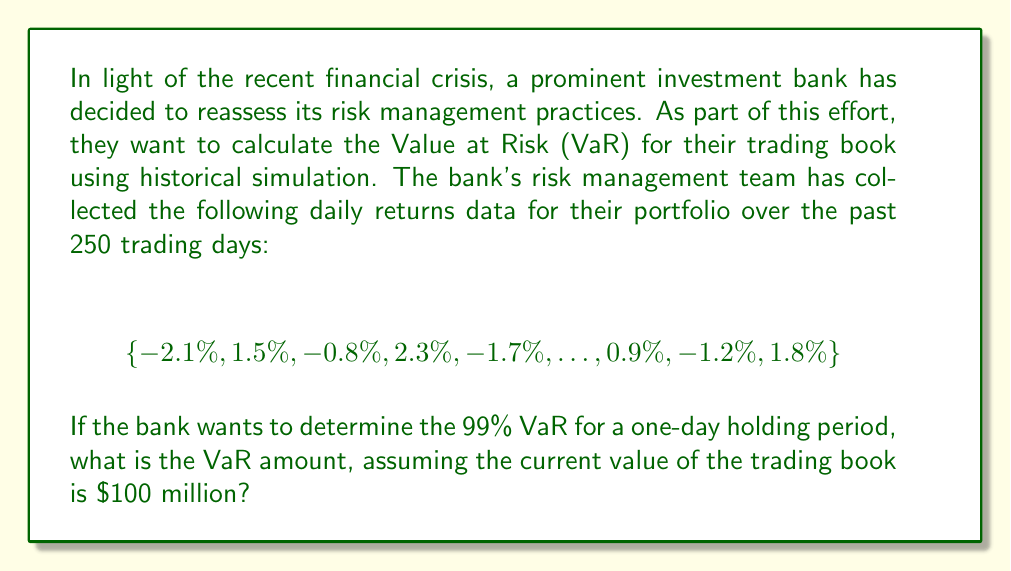What is the answer to this math problem? To calculate the Value at Risk (VaR) using historical simulation, we follow these steps:

1) First, we need to understand what 99% VaR means. It represents the potential loss that is expected to be exceeded only 1% of the time over the given holding period (in this case, one day).

2) With 250 trading days of historical data, we need to find the 3rd worst return (1% of 250 is 2.5, rounded up to 3).

3) Sort the returns from worst (most negative) to best (most positive).

4) Identify the 3rd worst return. Let's assume it's -2.5%.

5) The VaR is then calculated by applying this return to the current value of the trading book:

   $$VaR = \text{Current Value} \times |\text{3rd Worst Return}|$$
   
   $$VaR = \$100,000,000 \times 0.025 = \$2,500,000$$

This means that with 99% confidence, the bank can expect that its losses will not exceed $2.5 million over the next trading day.

Note: In practice, financial institutions often use much larger datasets and more sophisticated models to calculate VaR. They may also consider factors such as market volatility, correlations between different assets, and potential extreme events.
Answer: The 99% one-day Value at Risk (VaR) for the trading book is $2,500,000. 